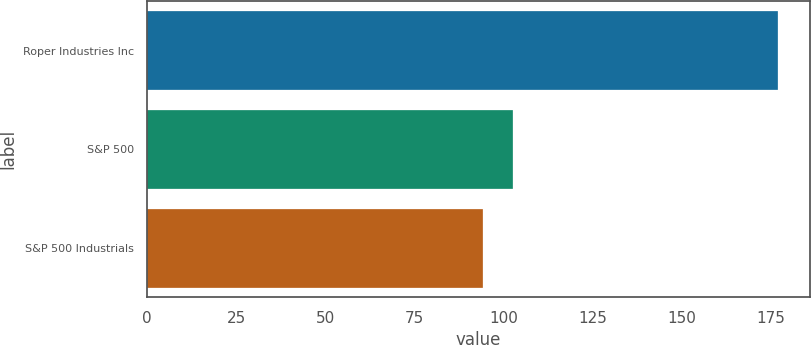Convert chart. <chart><loc_0><loc_0><loc_500><loc_500><bar_chart><fcel>Roper Industries Inc<fcel>S&P 500<fcel>S&P 500 Industrials<nl><fcel>177<fcel>102.61<fcel>94.35<nl></chart> 